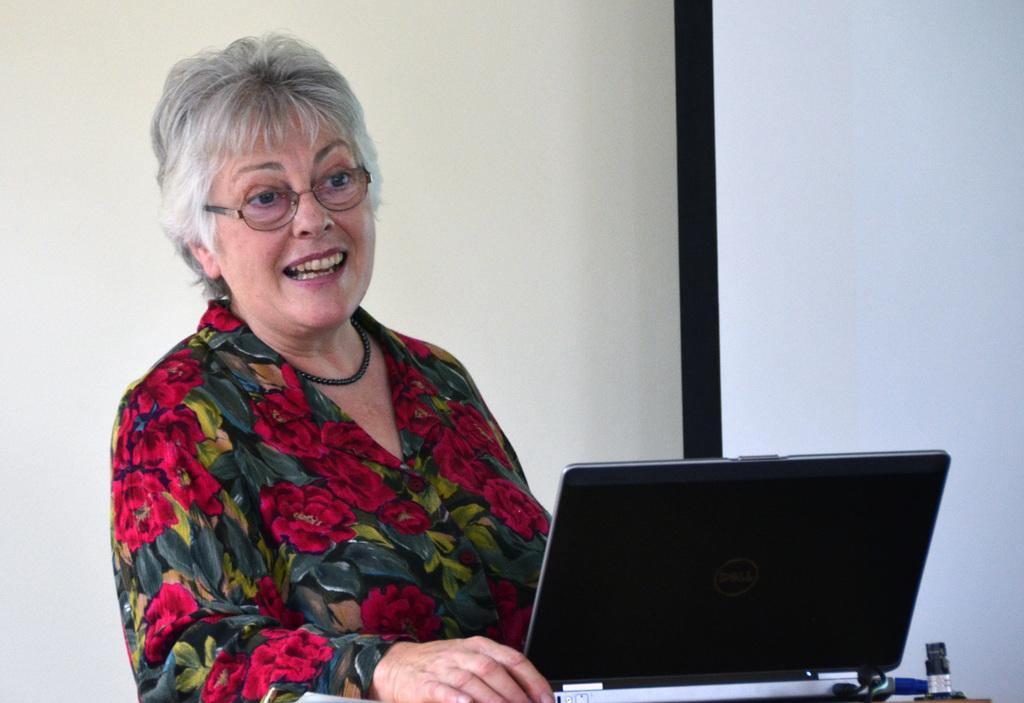Who is present in the image? There is a woman in the image. What is the woman doing in the image? The woman is smiling in the image. How is the woman dressed in the image? The woman is wearing red color clothing with flowers and is also wearing spectacles. What can be seen on the right side of the image? There is a laptop on the right side of the image. What is the color of the laptop? The laptop is black in color. What type of wool is being used to create the bead necklace in the image? There is no wool or bead necklace present in the image. 